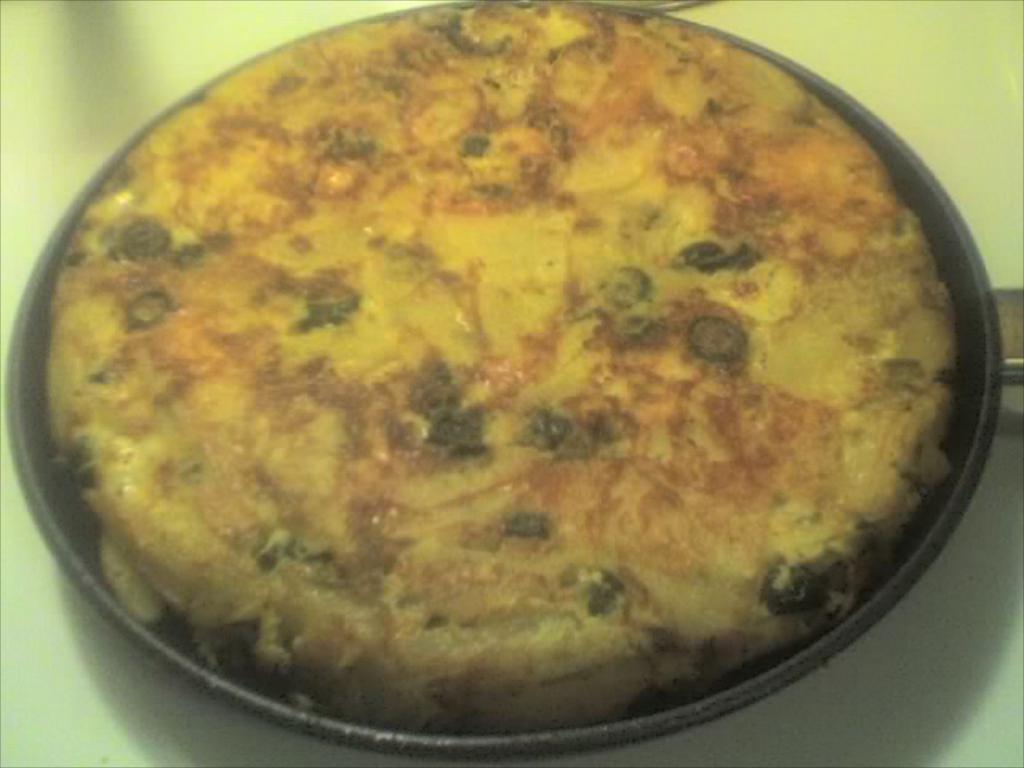Describe this image in one or two sentences. In this picture we can observe some food places in the black color pan. The pan is placed on the table which is in white color. 